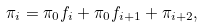Convert formula to latex. <formula><loc_0><loc_0><loc_500><loc_500>\pi _ { i } = \pi _ { 0 } f _ { i } + \pi _ { 0 } f _ { i + 1 } + \pi _ { i + 2 } ,</formula> 